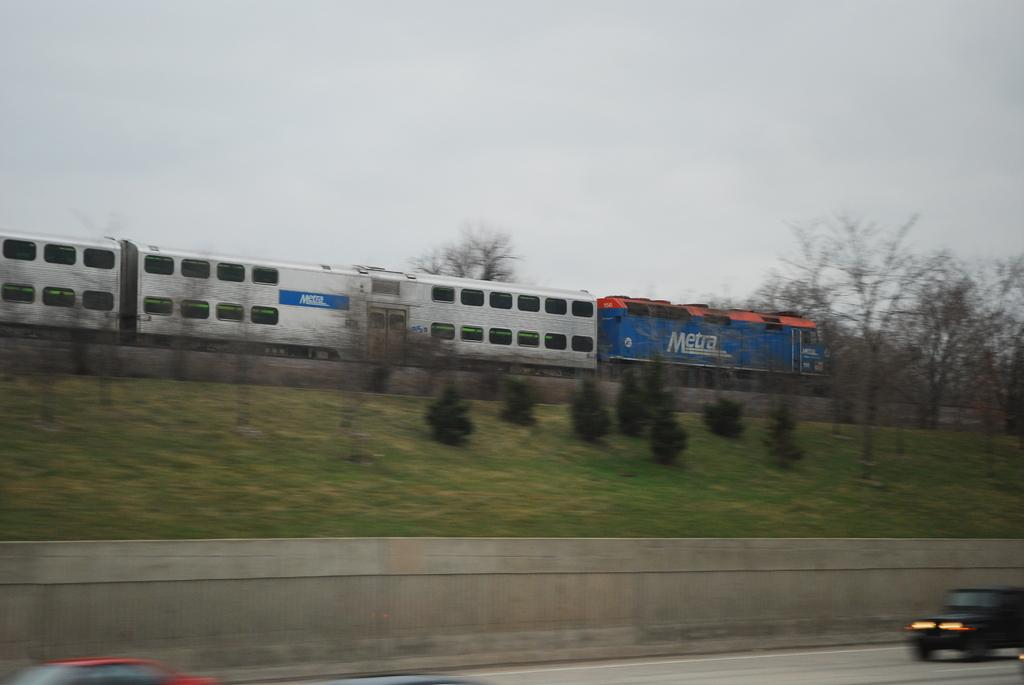What is the main subject of the image? There is a train in the image. What type of vegetation can be seen in the image? Plants, grass, and trees are visible in the image. What is visible in the background of the image? The sky is visible in the image. What is happening at the bottom of the image? Vehicles are passing on the road at the bottom of the image. What type of pan is being used to cook the train in the image? There is no pan present in the image, and the train is not being cooked. 